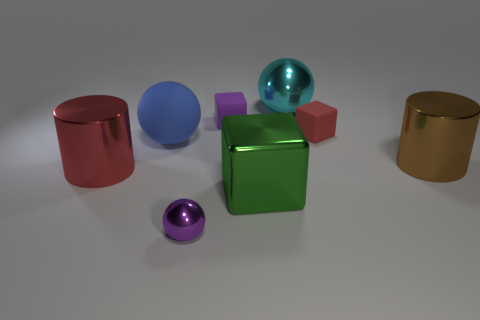Add 1 big green metal cylinders. How many objects exist? 9 Subtract all cylinders. How many objects are left? 6 Subtract 0 yellow blocks. How many objects are left? 8 Subtract all large cylinders. Subtract all cyan metal things. How many objects are left? 5 Add 4 big green things. How many big green things are left? 5 Add 2 small yellow matte blocks. How many small yellow matte blocks exist? 2 